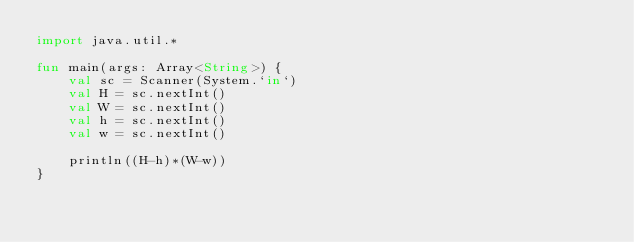Convert code to text. <code><loc_0><loc_0><loc_500><loc_500><_Kotlin_>import java.util.*

fun main(args: Array<String>) {
    val sc = Scanner(System.`in`)
    val H = sc.nextInt()
    val W = sc.nextInt()
    val h = sc.nextInt()
    val w = sc.nextInt()

    println((H-h)*(W-w))
}</code> 